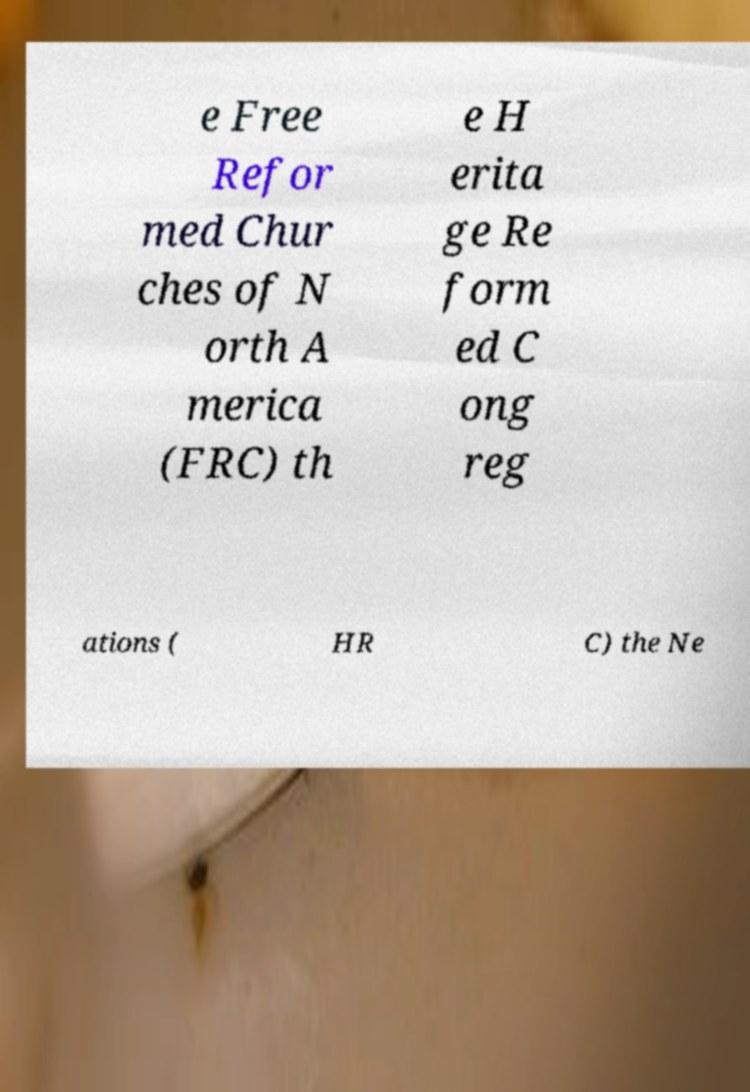Please read and relay the text visible in this image. What does it say? e Free Refor med Chur ches of N orth A merica (FRC) th e H erita ge Re form ed C ong reg ations ( HR C) the Ne 